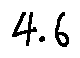<formula> <loc_0><loc_0><loc_500><loc_500>4 . 6</formula> 